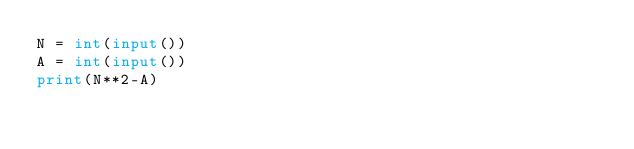<code> <loc_0><loc_0><loc_500><loc_500><_Python_>N = int(input())
A = int(input())
print(N**2-A)
</code> 